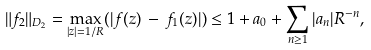<formula> <loc_0><loc_0><loc_500><loc_500>\| f _ { 2 } \| _ { D _ { 2 } } & = \max _ { | z | = 1 / R } ( | f ( z ) \, - \, f _ { 1 } ( z ) | ) \leq 1 + a _ { 0 } + \sum _ { n \geq 1 } | a _ { n } | R ^ { - n } ,</formula> 